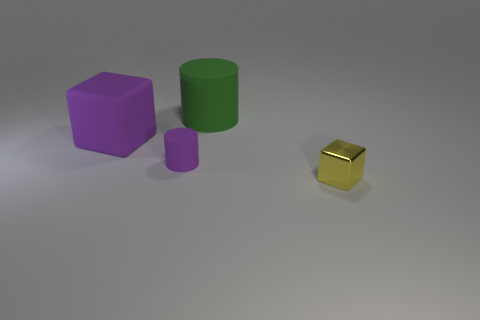What material is the other large purple object that is the same shape as the metal thing?
Provide a short and direct response. Rubber. What number of other things are there of the same size as the metallic thing?
Your answer should be compact. 1. What is the big green thing made of?
Your response must be concise. Rubber. Is the number of large green cylinders in front of the shiny thing greater than the number of big purple metallic cubes?
Provide a succinct answer. No. Are there any big matte things?
Give a very brief answer. Yes. What number of other things are the same shape as the green object?
Your answer should be very brief. 1. There is a big matte thing that is in front of the large cylinder; is it the same color as the matte cylinder that is in front of the big green thing?
Offer a terse response. Yes. There is a rubber cylinder that is behind the cylinder in front of the big matte object that is on the left side of the large green rubber cylinder; what size is it?
Offer a very short reply. Large. There is a matte object that is right of the big rubber block and in front of the big green matte thing; what shape is it?
Your response must be concise. Cylinder. Is the number of large matte things in front of the large purple matte thing the same as the number of small yellow objects that are behind the tiny matte object?
Keep it short and to the point. Yes. 